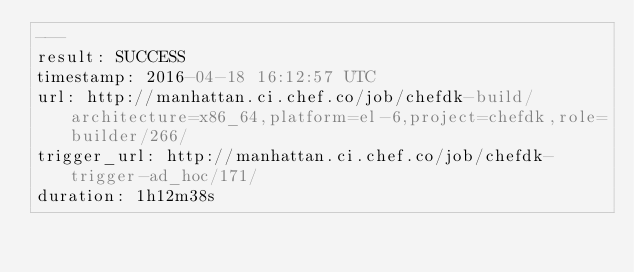<code> <loc_0><loc_0><loc_500><loc_500><_YAML_>---
result: SUCCESS
timestamp: 2016-04-18 16:12:57 UTC
url: http://manhattan.ci.chef.co/job/chefdk-build/architecture=x86_64,platform=el-6,project=chefdk,role=builder/266/
trigger_url: http://manhattan.ci.chef.co/job/chefdk-trigger-ad_hoc/171/
duration: 1h12m38s
</code> 